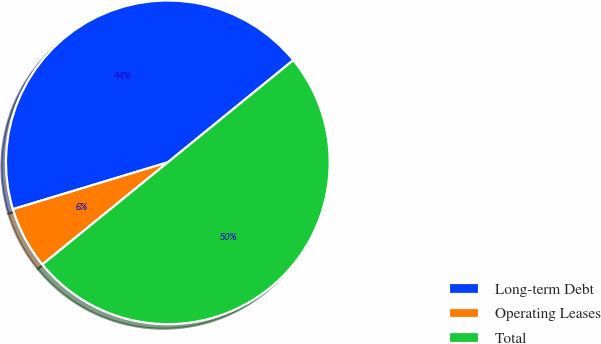<chart> <loc_0><loc_0><loc_500><loc_500><pie_chart><fcel>Long-term Debt<fcel>Operating Leases<fcel>Total<nl><fcel>43.8%<fcel>6.2%<fcel>50.0%<nl></chart> 